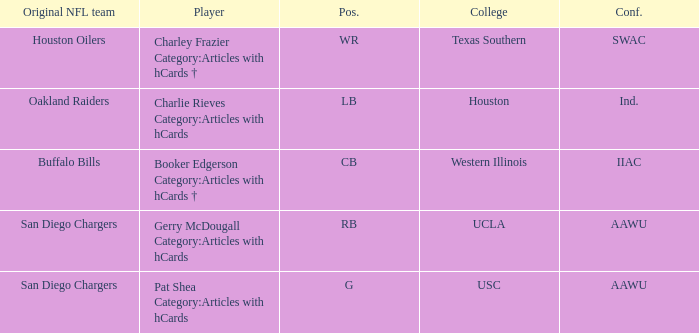What player's original team are the Oakland Raiders? Charlie Rieves Category:Articles with hCards. 